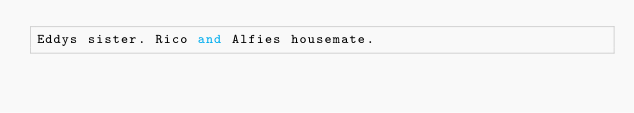<code> <loc_0><loc_0><loc_500><loc_500><_FORTRAN_>Eddys sister. Rico and Alfies housemate.

</code> 